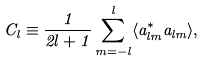Convert formula to latex. <formula><loc_0><loc_0><loc_500><loc_500>C _ { l } \equiv \frac { 1 } { 2 l + 1 } \sum _ { m = - l } ^ { l } \langle a _ { l m } ^ { * } a _ { l m } \rangle ,</formula> 